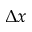<formula> <loc_0><loc_0><loc_500><loc_500>\Delta x</formula> 